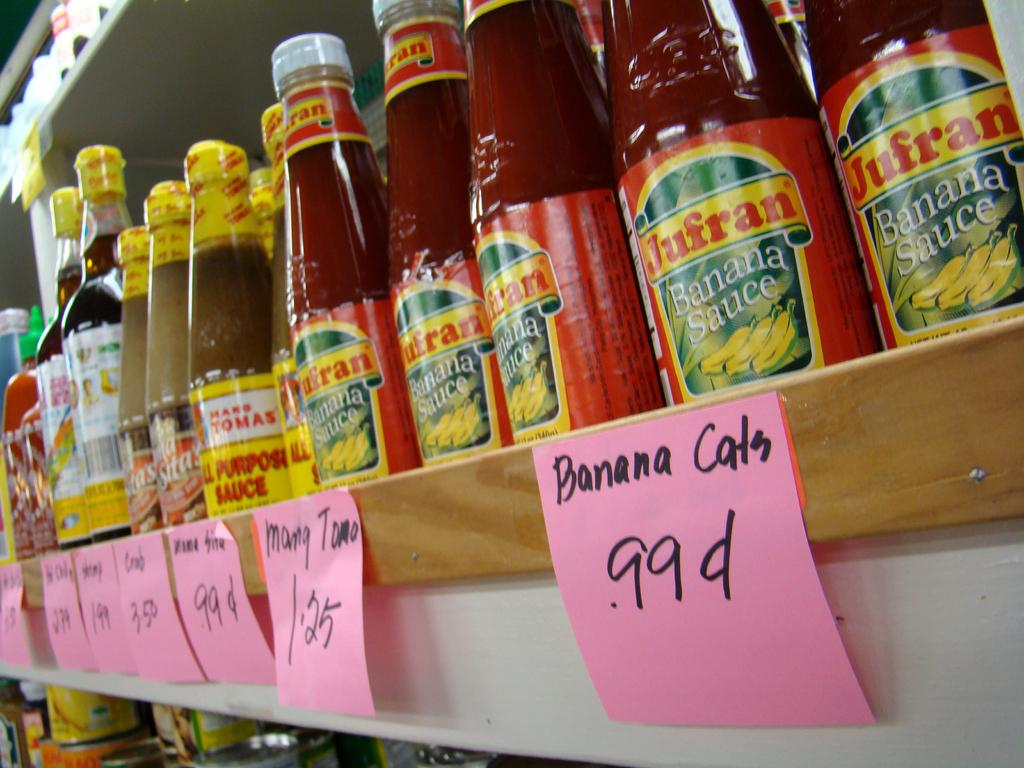<image>
Present a compact description of the photo's key features. Bottles of banana sauce are lined up with other sauces on a shelf with the price noted on pink slips of paper. 